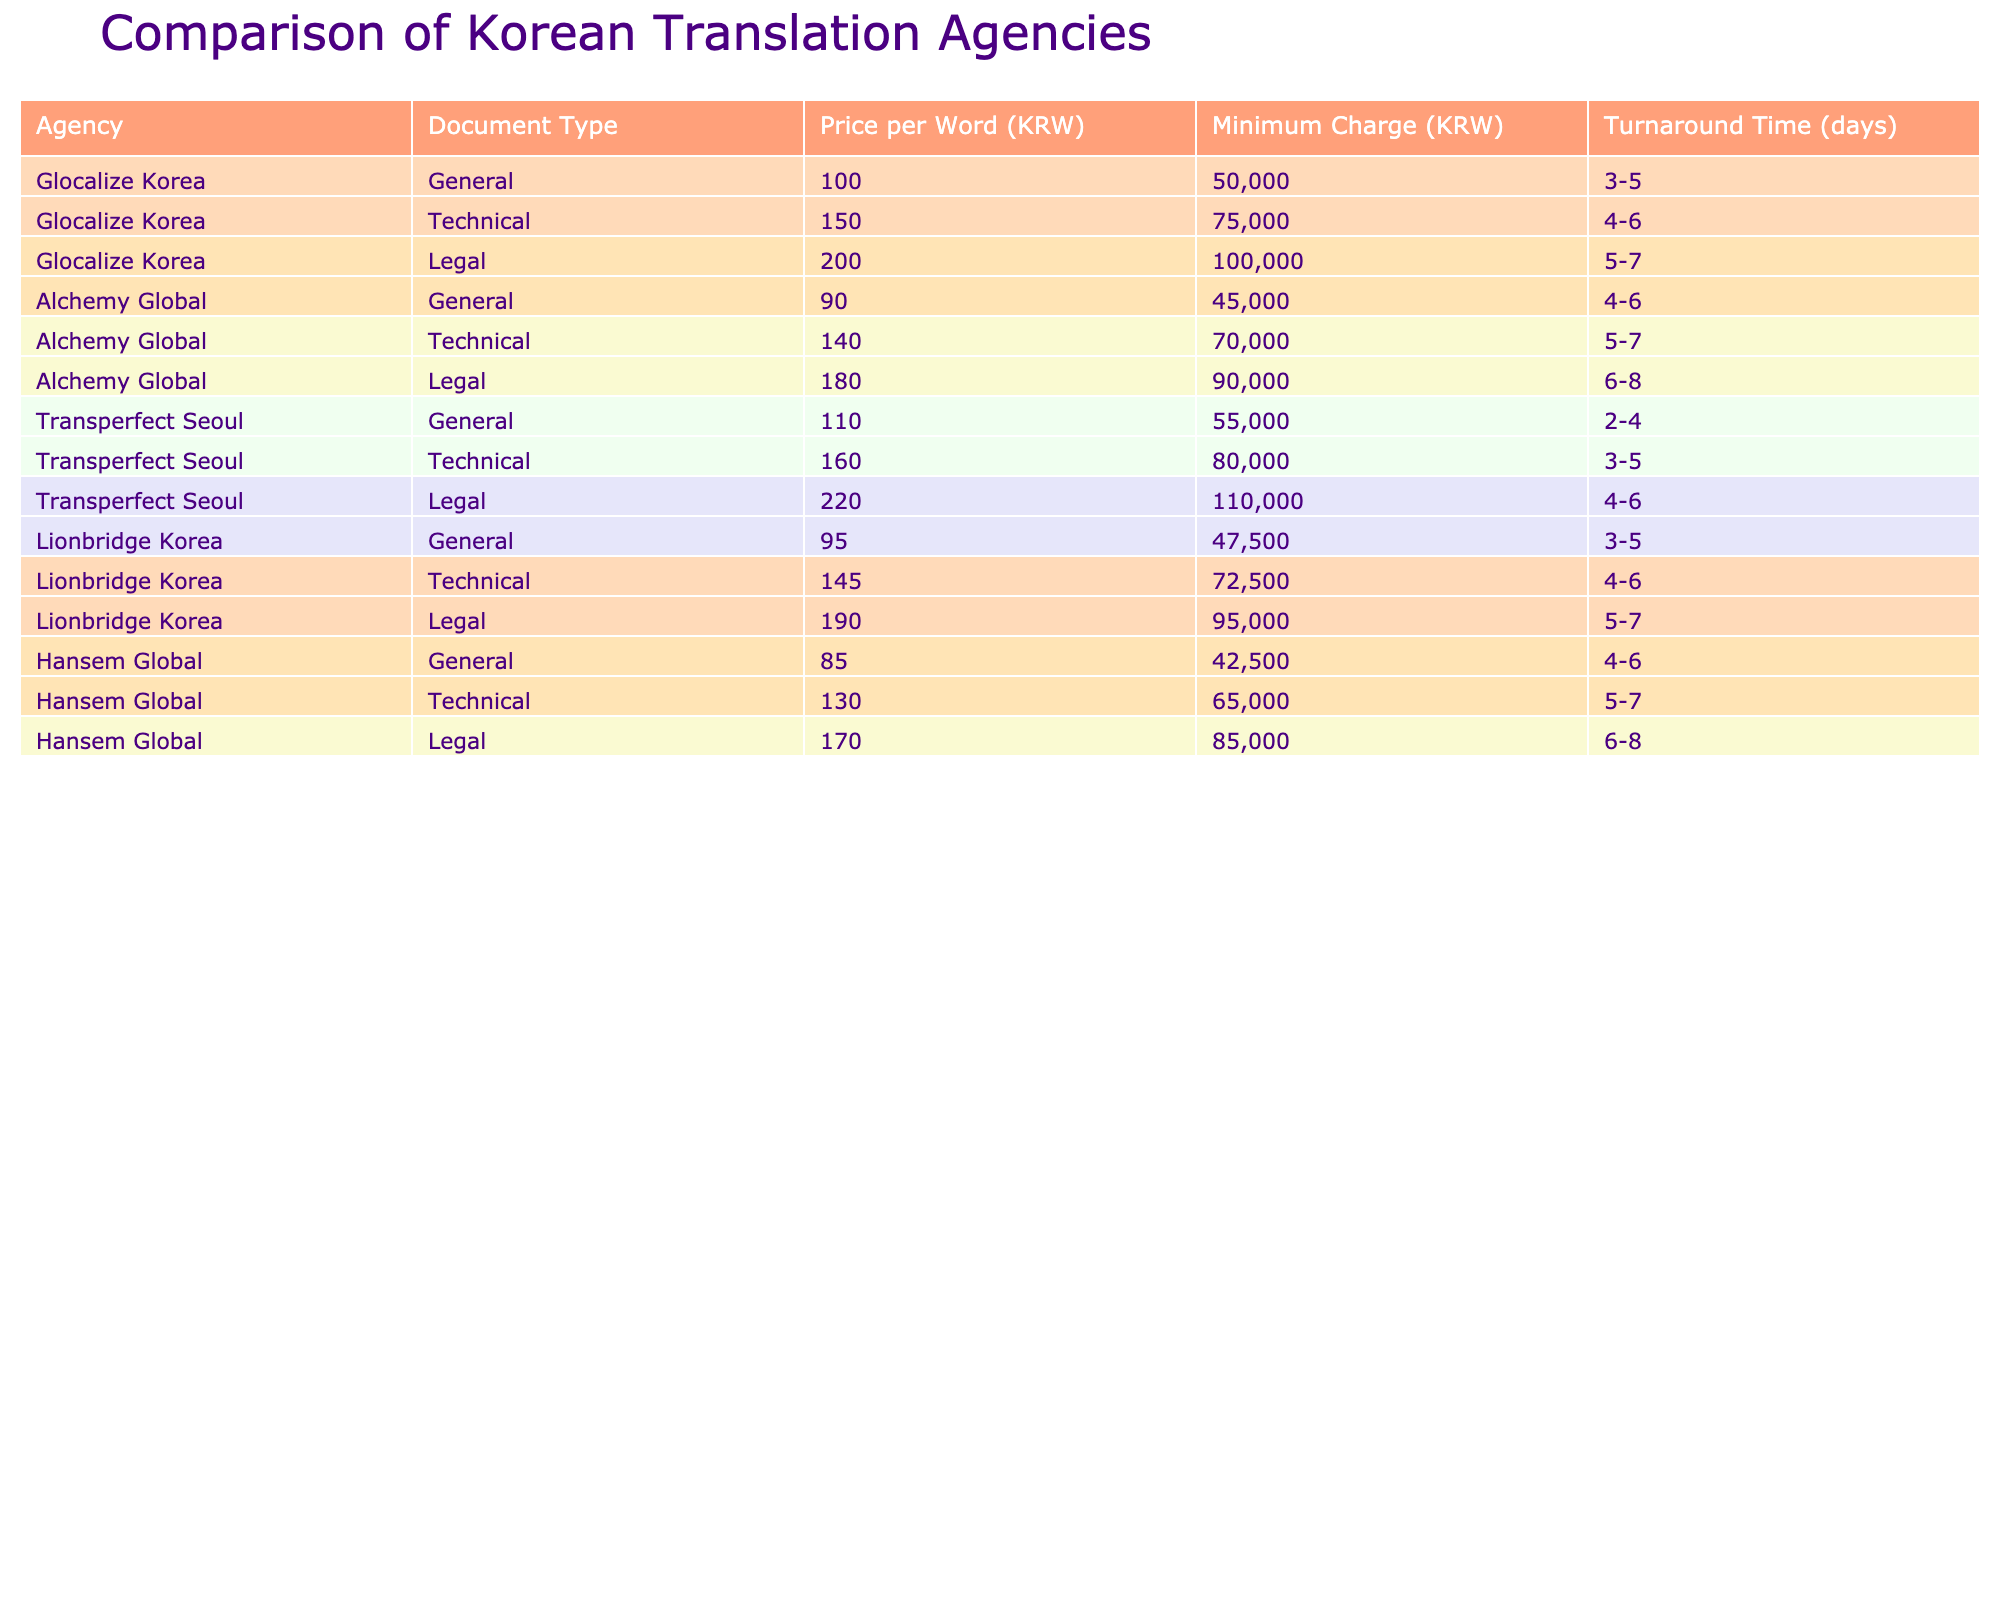What is the lowest minimum charge among the agencies for general documents? The general documents from Hansem Global have the lowest minimum charge of 42,500 KRW, which is lower than the charges from all other agencies listed in the table.
Answer: 42,500 KRW Which agency has the highest price per word for legal documents? Transperfect Seoul charges 220 KRW per word for legal documents, which is the highest rate compared to the other agencies listed in the table.
Answer: 220 KRW How much cheaper is Alchemy Global's minimum charge for general documents compared to Transperfect Seoul's? Transperfect Seoul's minimum charge for general documents is 55,000 KRW. Alchemy Global's minimum charge is 45,000 KRW. The difference is 55,000 - 45,000 = 10,000 KRW.
Answer: 10,000 KRW Do any agencies offer a turnaround time of 3 days for legal documents? No, the shortest turnaround time for legal documents is 4 days offered by both Transperfect Seoul and Lionbridge Korea. Thus, no agency has a turnaround time of 3 days for legal documents.
Answer: No What is the average price per word for technical documents across all agencies? The prices per word for technical documents are: 150 (Glocalize Korea) + 140 (Alchemy Global) + 160 (Transperfect Seoul) + 145 (Lionbridge Korea) + 130 (Hansem Global) = 725. There are 5 agencies, so the average is 725 / 5 = 145.
Answer: 145 KRW 